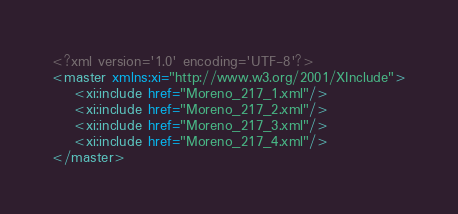<code> <loc_0><loc_0><loc_500><loc_500><_XML_><?xml version='1.0' encoding='UTF-8'?>
<master xmlns:xi="http://www.w3.org/2001/XInclude">
    <xi:include href="Moreno_217_1.xml"/>
    <xi:include href="Moreno_217_2.xml"/>
    <xi:include href="Moreno_217_3.xml"/>
    <xi:include href="Moreno_217_4.xml"/>
</master>
</code> 